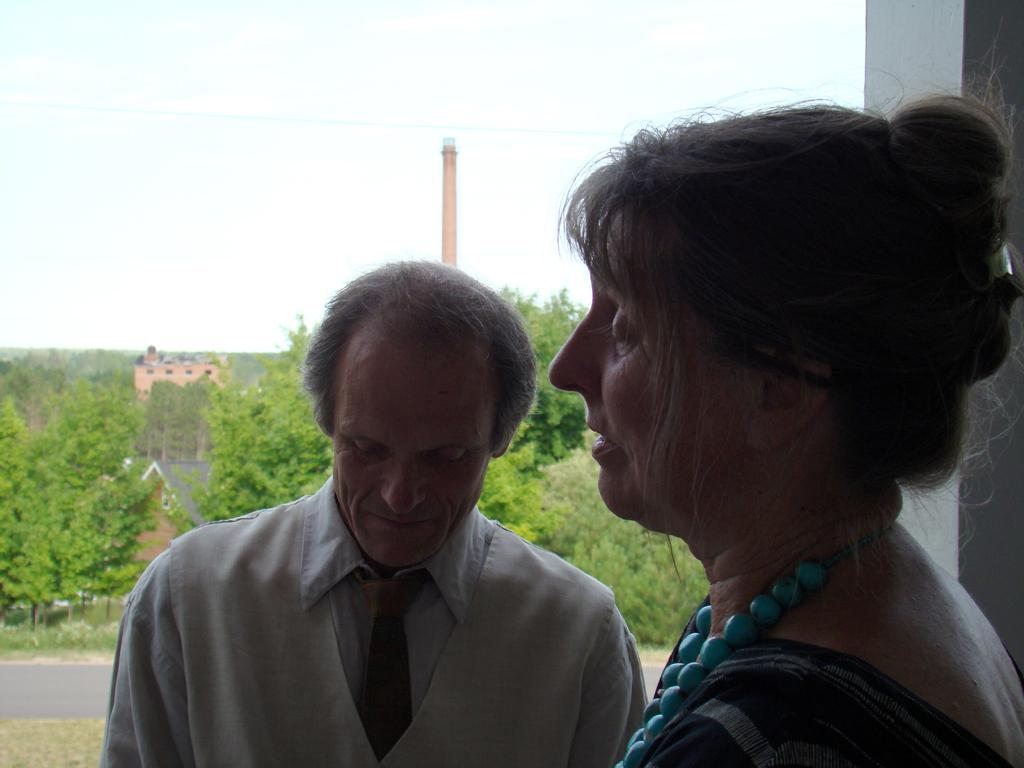How many people are present in the image? There is a man and a woman in the image. What can be seen in the background of the image? There are trees and the sky visible in the background of the image. What type of stew is being prepared by the maid in the image? There is no maid or stew present in the image; it features a man and a woman with trees and the sky in the background. 